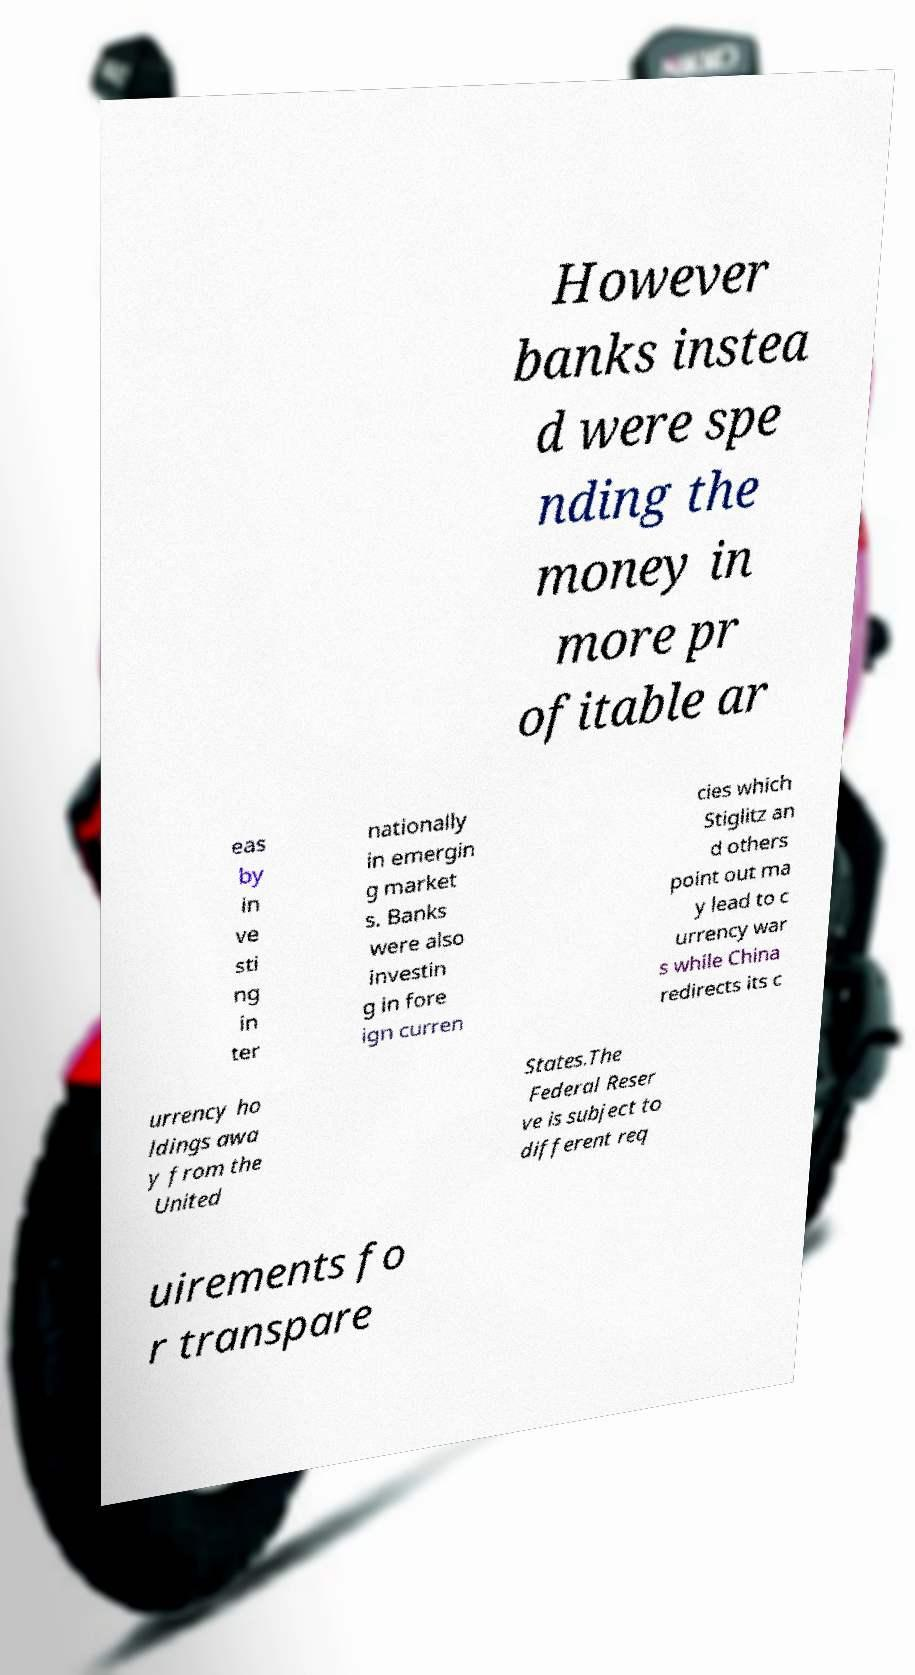Can you read and provide the text displayed in the image?This photo seems to have some interesting text. Can you extract and type it out for me? However banks instea d were spe nding the money in more pr ofitable ar eas by in ve sti ng in ter nationally in emergin g market s. Banks were also investin g in fore ign curren cies which Stiglitz an d others point out ma y lead to c urrency war s while China redirects its c urrency ho ldings awa y from the United States.The Federal Reser ve is subject to different req uirements fo r transpare 